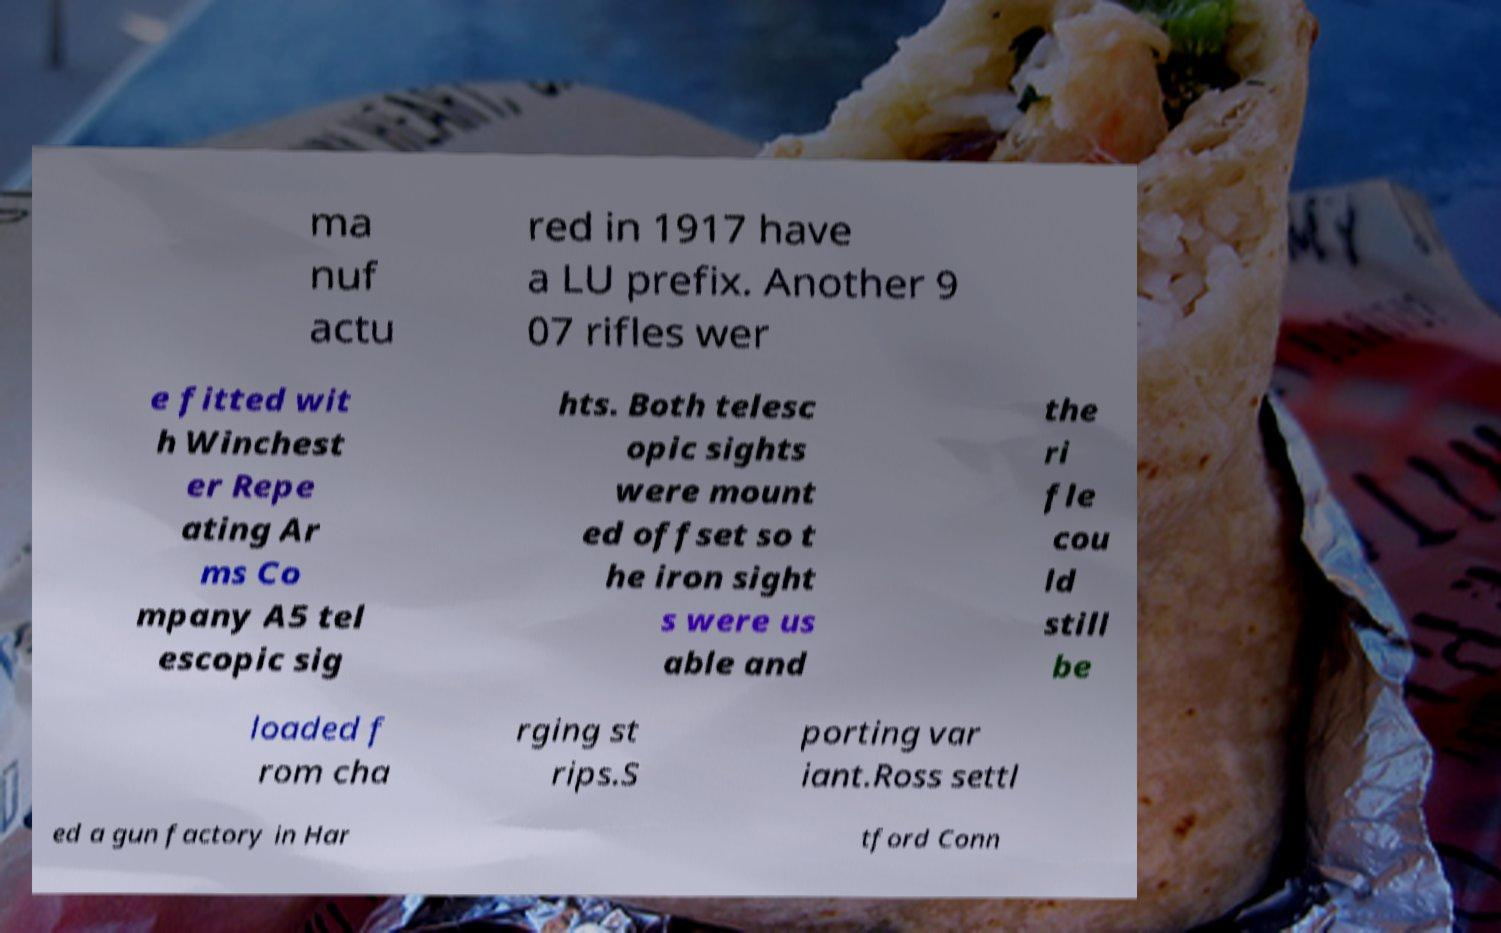Could you assist in decoding the text presented in this image and type it out clearly? ma nuf actu red in 1917 have a LU prefix. Another 9 07 rifles wer e fitted wit h Winchest er Repe ating Ar ms Co mpany A5 tel escopic sig hts. Both telesc opic sights were mount ed offset so t he iron sight s were us able and the ri fle cou ld still be loaded f rom cha rging st rips.S porting var iant.Ross settl ed a gun factory in Har tford Conn 